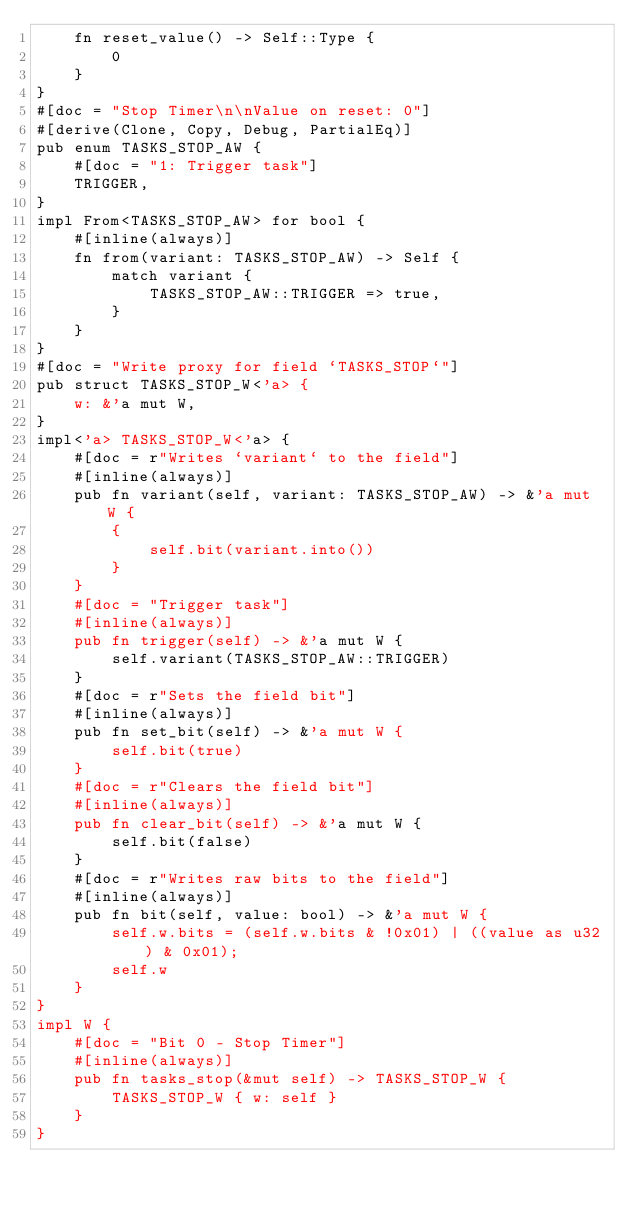<code> <loc_0><loc_0><loc_500><loc_500><_Rust_>    fn reset_value() -> Self::Type {
        0
    }
}
#[doc = "Stop Timer\n\nValue on reset: 0"]
#[derive(Clone, Copy, Debug, PartialEq)]
pub enum TASKS_STOP_AW {
    #[doc = "1: Trigger task"]
    TRIGGER,
}
impl From<TASKS_STOP_AW> for bool {
    #[inline(always)]
    fn from(variant: TASKS_STOP_AW) -> Self {
        match variant {
            TASKS_STOP_AW::TRIGGER => true,
        }
    }
}
#[doc = "Write proxy for field `TASKS_STOP`"]
pub struct TASKS_STOP_W<'a> {
    w: &'a mut W,
}
impl<'a> TASKS_STOP_W<'a> {
    #[doc = r"Writes `variant` to the field"]
    #[inline(always)]
    pub fn variant(self, variant: TASKS_STOP_AW) -> &'a mut W {
        {
            self.bit(variant.into())
        }
    }
    #[doc = "Trigger task"]
    #[inline(always)]
    pub fn trigger(self) -> &'a mut W {
        self.variant(TASKS_STOP_AW::TRIGGER)
    }
    #[doc = r"Sets the field bit"]
    #[inline(always)]
    pub fn set_bit(self) -> &'a mut W {
        self.bit(true)
    }
    #[doc = r"Clears the field bit"]
    #[inline(always)]
    pub fn clear_bit(self) -> &'a mut W {
        self.bit(false)
    }
    #[doc = r"Writes raw bits to the field"]
    #[inline(always)]
    pub fn bit(self, value: bool) -> &'a mut W {
        self.w.bits = (self.w.bits & !0x01) | ((value as u32) & 0x01);
        self.w
    }
}
impl W {
    #[doc = "Bit 0 - Stop Timer"]
    #[inline(always)]
    pub fn tasks_stop(&mut self) -> TASKS_STOP_W {
        TASKS_STOP_W { w: self }
    }
}
</code> 